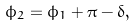Convert formula to latex. <formula><loc_0><loc_0><loc_500><loc_500>\phi _ { 2 } = \phi _ { 1 } + \pi - \delta ,</formula> 